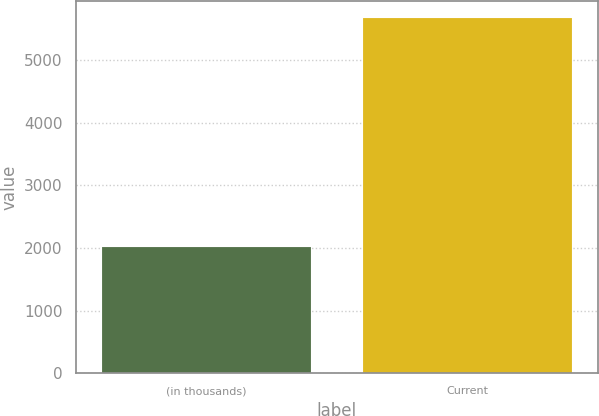Convert chart to OTSL. <chart><loc_0><loc_0><loc_500><loc_500><bar_chart><fcel>(in thousands)<fcel>Current<nl><fcel>2018<fcel>5667<nl></chart> 